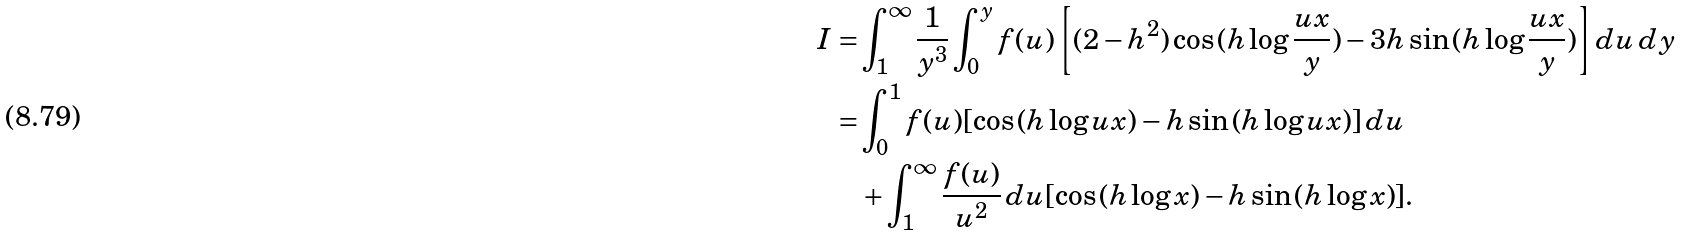<formula> <loc_0><loc_0><loc_500><loc_500>I = & \int _ { 1 } ^ { \infty } \frac { 1 } { y ^ { 3 } } \int _ { 0 } ^ { y } f ( u ) \left [ ( 2 - h ^ { 2 } ) \cos { ( h \log { \frac { u x } { y } } ) } - 3 h \sin { ( h \log { \frac { u x } { y } } ) } \right ] d u \, d y \\ = & \int _ { 0 } ^ { 1 } f ( u ) [ \cos { ( h \log { u x } ) } - h \sin { ( h \log { u x } ) } ] \, d u \\ & + \int _ { 1 } ^ { \infty } \frac { f ( u ) } { u ^ { 2 } } \, d u [ \cos { ( h \log { x } ) } - h \sin { ( h \log { x } ) } ] .</formula> 